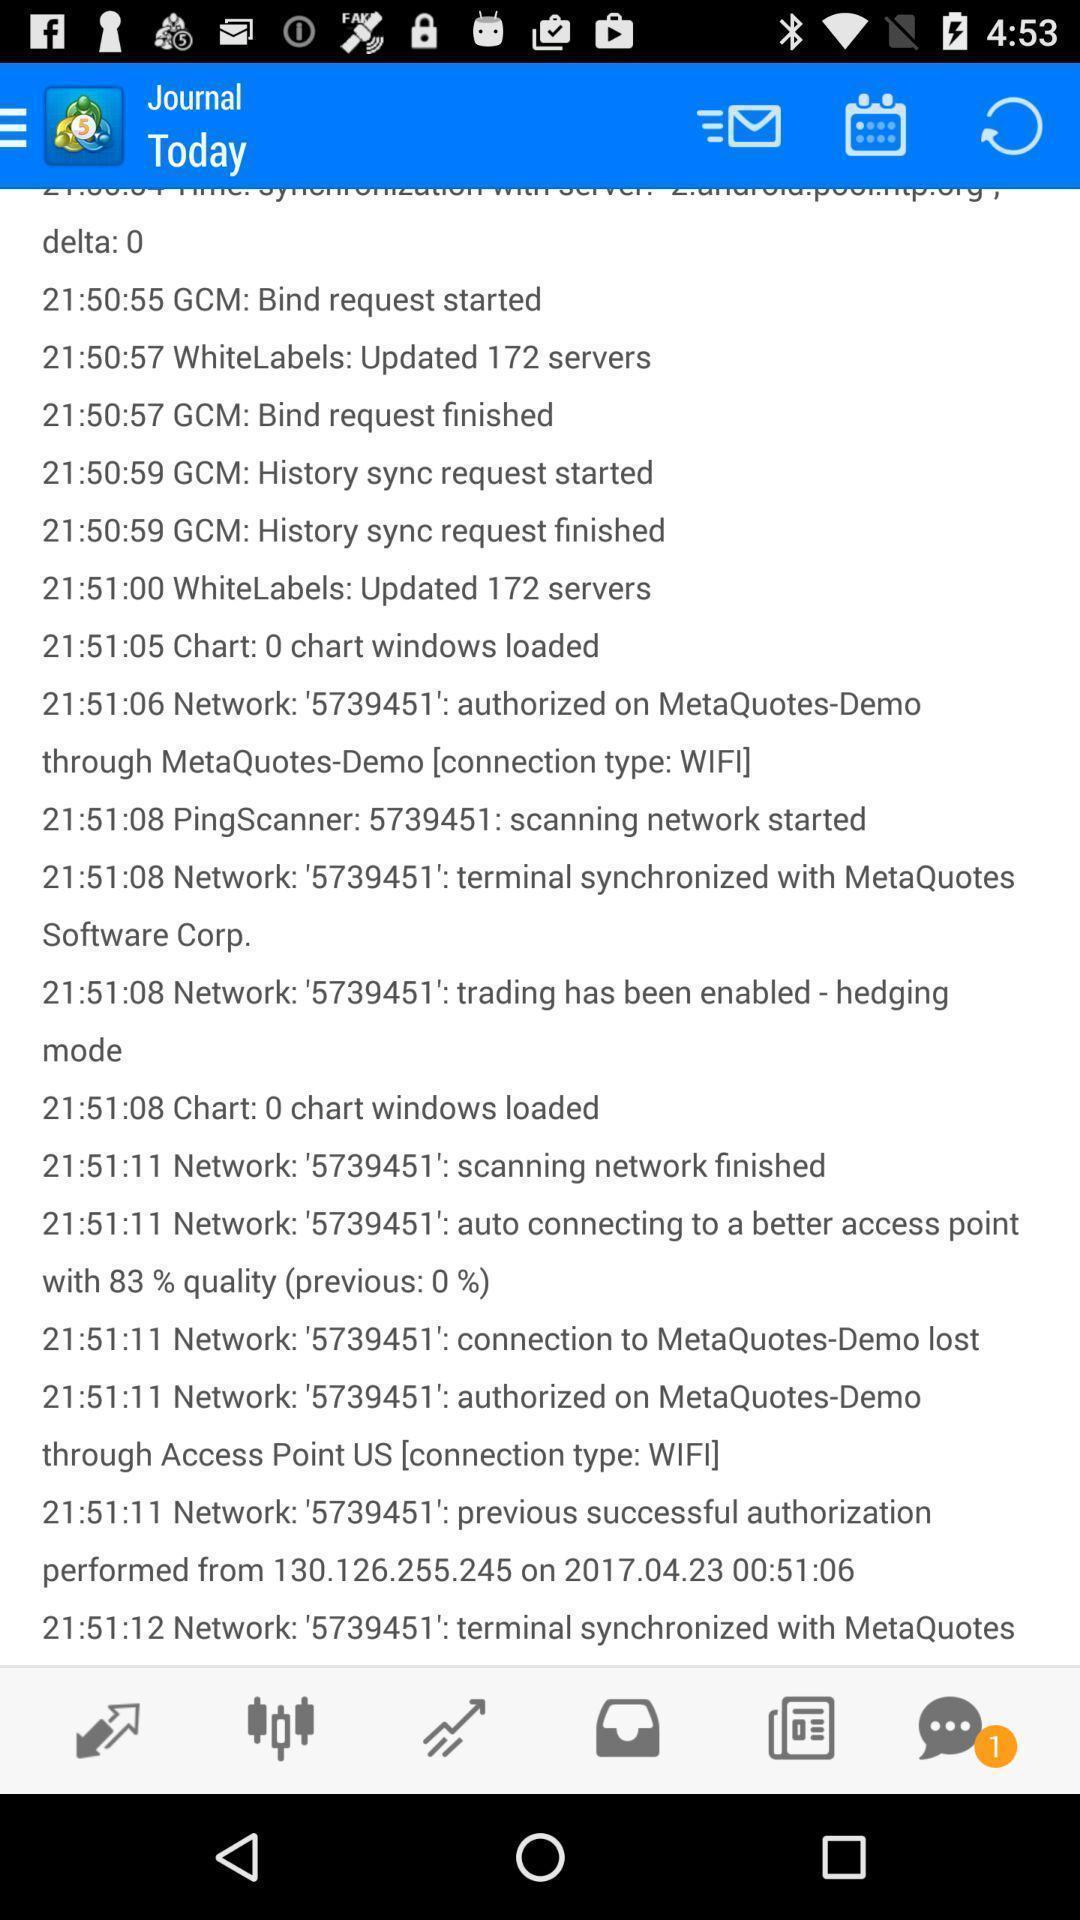Provide a detailed account of this screenshot. Screen shows journal with multiple options. 